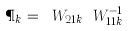<formula> <loc_0><loc_0><loc_500><loc_500>\P _ { k } = \ W _ { 2 1 k } \ W _ { 1 1 k } ^ { - 1 }</formula> 